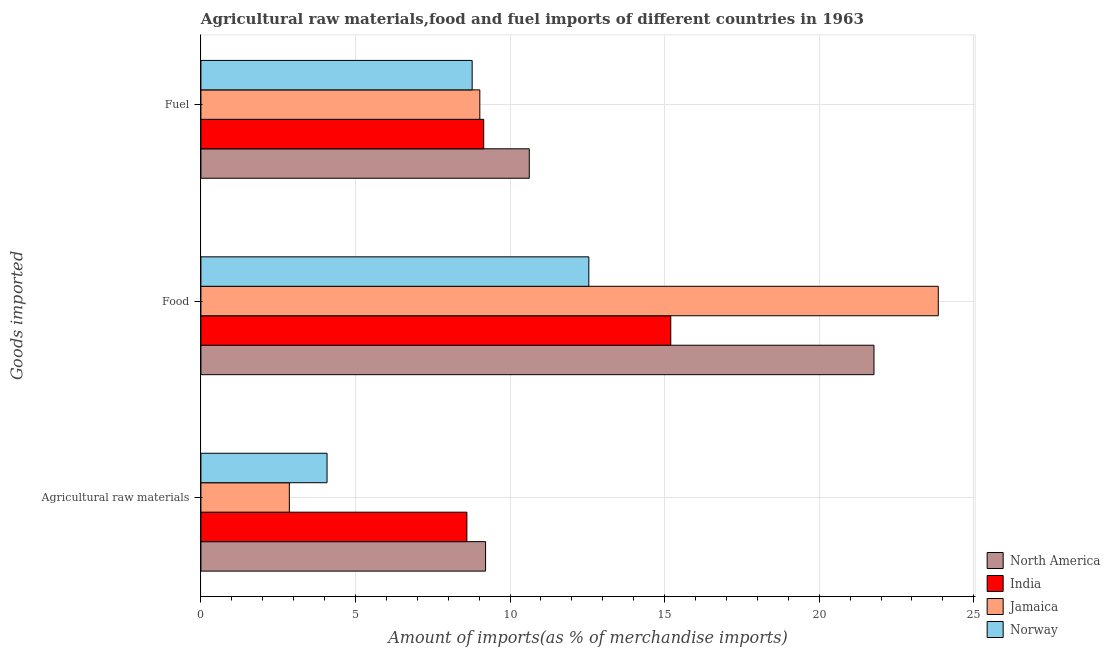How many groups of bars are there?
Offer a very short reply. 3. Are the number of bars per tick equal to the number of legend labels?
Keep it short and to the point. Yes. How many bars are there on the 2nd tick from the top?
Your answer should be very brief. 4. What is the label of the 2nd group of bars from the top?
Ensure brevity in your answer.  Food. What is the percentage of raw materials imports in India?
Offer a very short reply. 8.6. Across all countries, what is the maximum percentage of food imports?
Ensure brevity in your answer.  23.85. Across all countries, what is the minimum percentage of fuel imports?
Your answer should be very brief. 8.77. In which country was the percentage of fuel imports maximum?
Your answer should be compact. North America. In which country was the percentage of food imports minimum?
Your response must be concise. Norway. What is the total percentage of fuel imports in the graph?
Your answer should be very brief. 37.56. What is the difference between the percentage of raw materials imports in India and that in Jamaica?
Give a very brief answer. 5.74. What is the difference between the percentage of fuel imports in India and the percentage of raw materials imports in Jamaica?
Offer a terse response. 6.29. What is the average percentage of raw materials imports per country?
Give a very brief answer. 6.19. What is the difference between the percentage of fuel imports and percentage of raw materials imports in Jamaica?
Ensure brevity in your answer.  6.16. In how many countries, is the percentage of raw materials imports greater than 4 %?
Provide a short and direct response. 3. What is the ratio of the percentage of raw materials imports in Norway to that in North America?
Give a very brief answer. 0.44. Is the difference between the percentage of fuel imports in Norway and Jamaica greater than the difference between the percentage of raw materials imports in Norway and Jamaica?
Ensure brevity in your answer.  No. What is the difference between the highest and the second highest percentage of food imports?
Your answer should be compact. 2.08. What is the difference between the highest and the lowest percentage of fuel imports?
Your answer should be compact. 1.85. Is the sum of the percentage of raw materials imports in India and Norway greater than the maximum percentage of fuel imports across all countries?
Your response must be concise. Yes. How many countries are there in the graph?
Ensure brevity in your answer.  4. Does the graph contain any zero values?
Your answer should be compact. No. How are the legend labels stacked?
Provide a short and direct response. Vertical. What is the title of the graph?
Provide a succinct answer. Agricultural raw materials,food and fuel imports of different countries in 1963. Does "Antigua and Barbuda" appear as one of the legend labels in the graph?
Your response must be concise. No. What is the label or title of the X-axis?
Ensure brevity in your answer.  Amount of imports(as % of merchandise imports). What is the label or title of the Y-axis?
Offer a very short reply. Goods imported. What is the Amount of imports(as % of merchandise imports) of North America in Agricultural raw materials?
Give a very brief answer. 9.21. What is the Amount of imports(as % of merchandise imports) in India in Agricultural raw materials?
Offer a very short reply. 8.6. What is the Amount of imports(as % of merchandise imports) of Jamaica in Agricultural raw materials?
Offer a very short reply. 2.86. What is the Amount of imports(as % of merchandise imports) in Norway in Agricultural raw materials?
Offer a terse response. 4.08. What is the Amount of imports(as % of merchandise imports) in North America in Food?
Keep it short and to the point. 21.77. What is the Amount of imports(as % of merchandise imports) in India in Food?
Make the answer very short. 15.2. What is the Amount of imports(as % of merchandise imports) of Jamaica in Food?
Your answer should be compact. 23.85. What is the Amount of imports(as % of merchandise imports) in Norway in Food?
Your response must be concise. 12.55. What is the Amount of imports(as % of merchandise imports) in North America in Fuel?
Ensure brevity in your answer.  10.62. What is the Amount of imports(as % of merchandise imports) in India in Fuel?
Make the answer very short. 9.15. What is the Amount of imports(as % of merchandise imports) of Jamaica in Fuel?
Ensure brevity in your answer.  9.02. What is the Amount of imports(as % of merchandise imports) in Norway in Fuel?
Ensure brevity in your answer.  8.77. Across all Goods imported, what is the maximum Amount of imports(as % of merchandise imports) of North America?
Offer a very short reply. 21.77. Across all Goods imported, what is the maximum Amount of imports(as % of merchandise imports) in India?
Keep it short and to the point. 15.2. Across all Goods imported, what is the maximum Amount of imports(as % of merchandise imports) in Jamaica?
Keep it short and to the point. 23.85. Across all Goods imported, what is the maximum Amount of imports(as % of merchandise imports) of Norway?
Provide a succinct answer. 12.55. Across all Goods imported, what is the minimum Amount of imports(as % of merchandise imports) in North America?
Make the answer very short. 9.21. Across all Goods imported, what is the minimum Amount of imports(as % of merchandise imports) of India?
Provide a succinct answer. 8.6. Across all Goods imported, what is the minimum Amount of imports(as % of merchandise imports) in Jamaica?
Your answer should be compact. 2.86. Across all Goods imported, what is the minimum Amount of imports(as % of merchandise imports) of Norway?
Make the answer very short. 4.08. What is the total Amount of imports(as % of merchandise imports) of North America in the graph?
Provide a succinct answer. 41.6. What is the total Amount of imports(as % of merchandise imports) of India in the graph?
Ensure brevity in your answer.  32.95. What is the total Amount of imports(as % of merchandise imports) in Jamaica in the graph?
Your response must be concise. 35.73. What is the total Amount of imports(as % of merchandise imports) in Norway in the graph?
Provide a succinct answer. 25.4. What is the difference between the Amount of imports(as % of merchandise imports) of North America in Agricultural raw materials and that in Food?
Your response must be concise. -12.56. What is the difference between the Amount of imports(as % of merchandise imports) of India in Agricultural raw materials and that in Food?
Provide a succinct answer. -6.59. What is the difference between the Amount of imports(as % of merchandise imports) in Jamaica in Agricultural raw materials and that in Food?
Provide a short and direct response. -20.99. What is the difference between the Amount of imports(as % of merchandise imports) in Norway in Agricultural raw materials and that in Food?
Give a very brief answer. -8.47. What is the difference between the Amount of imports(as % of merchandise imports) of North America in Agricultural raw materials and that in Fuel?
Your answer should be compact. -1.41. What is the difference between the Amount of imports(as % of merchandise imports) of India in Agricultural raw materials and that in Fuel?
Your response must be concise. -0.54. What is the difference between the Amount of imports(as % of merchandise imports) of Jamaica in Agricultural raw materials and that in Fuel?
Offer a terse response. -6.16. What is the difference between the Amount of imports(as % of merchandise imports) in Norway in Agricultural raw materials and that in Fuel?
Offer a very short reply. -4.69. What is the difference between the Amount of imports(as % of merchandise imports) of North America in Food and that in Fuel?
Your answer should be very brief. 11.15. What is the difference between the Amount of imports(as % of merchandise imports) in India in Food and that in Fuel?
Provide a succinct answer. 6.05. What is the difference between the Amount of imports(as % of merchandise imports) of Jamaica in Food and that in Fuel?
Your answer should be very brief. 14.83. What is the difference between the Amount of imports(as % of merchandise imports) in Norway in Food and that in Fuel?
Provide a succinct answer. 3.77. What is the difference between the Amount of imports(as % of merchandise imports) of North America in Agricultural raw materials and the Amount of imports(as % of merchandise imports) of India in Food?
Make the answer very short. -5.99. What is the difference between the Amount of imports(as % of merchandise imports) of North America in Agricultural raw materials and the Amount of imports(as % of merchandise imports) of Jamaica in Food?
Offer a very short reply. -14.64. What is the difference between the Amount of imports(as % of merchandise imports) of North America in Agricultural raw materials and the Amount of imports(as % of merchandise imports) of Norway in Food?
Make the answer very short. -3.34. What is the difference between the Amount of imports(as % of merchandise imports) of India in Agricultural raw materials and the Amount of imports(as % of merchandise imports) of Jamaica in Food?
Make the answer very short. -15.25. What is the difference between the Amount of imports(as % of merchandise imports) in India in Agricultural raw materials and the Amount of imports(as % of merchandise imports) in Norway in Food?
Make the answer very short. -3.94. What is the difference between the Amount of imports(as % of merchandise imports) of Jamaica in Agricultural raw materials and the Amount of imports(as % of merchandise imports) of Norway in Food?
Make the answer very short. -9.69. What is the difference between the Amount of imports(as % of merchandise imports) of North America in Agricultural raw materials and the Amount of imports(as % of merchandise imports) of India in Fuel?
Make the answer very short. 0.06. What is the difference between the Amount of imports(as % of merchandise imports) of North America in Agricultural raw materials and the Amount of imports(as % of merchandise imports) of Jamaica in Fuel?
Your answer should be compact. 0.19. What is the difference between the Amount of imports(as % of merchandise imports) in North America in Agricultural raw materials and the Amount of imports(as % of merchandise imports) in Norway in Fuel?
Provide a succinct answer. 0.43. What is the difference between the Amount of imports(as % of merchandise imports) of India in Agricultural raw materials and the Amount of imports(as % of merchandise imports) of Jamaica in Fuel?
Give a very brief answer. -0.42. What is the difference between the Amount of imports(as % of merchandise imports) in India in Agricultural raw materials and the Amount of imports(as % of merchandise imports) in Norway in Fuel?
Give a very brief answer. -0.17. What is the difference between the Amount of imports(as % of merchandise imports) of Jamaica in Agricultural raw materials and the Amount of imports(as % of merchandise imports) of Norway in Fuel?
Your response must be concise. -5.91. What is the difference between the Amount of imports(as % of merchandise imports) in North America in Food and the Amount of imports(as % of merchandise imports) in India in Fuel?
Offer a very short reply. 12.62. What is the difference between the Amount of imports(as % of merchandise imports) in North America in Food and the Amount of imports(as % of merchandise imports) in Jamaica in Fuel?
Your answer should be very brief. 12.75. What is the difference between the Amount of imports(as % of merchandise imports) in North America in Food and the Amount of imports(as % of merchandise imports) in Norway in Fuel?
Your response must be concise. 13. What is the difference between the Amount of imports(as % of merchandise imports) of India in Food and the Amount of imports(as % of merchandise imports) of Jamaica in Fuel?
Your answer should be compact. 6.18. What is the difference between the Amount of imports(as % of merchandise imports) of India in Food and the Amount of imports(as % of merchandise imports) of Norway in Fuel?
Keep it short and to the point. 6.42. What is the difference between the Amount of imports(as % of merchandise imports) in Jamaica in Food and the Amount of imports(as % of merchandise imports) in Norway in Fuel?
Your response must be concise. 15.08. What is the average Amount of imports(as % of merchandise imports) in North America per Goods imported?
Provide a succinct answer. 13.87. What is the average Amount of imports(as % of merchandise imports) of India per Goods imported?
Keep it short and to the point. 10.98. What is the average Amount of imports(as % of merchandise imports) in Jamaica per Goods imported?
Your answer should be compact. 11.91. What is the average Amount of imports(as % of merchandise imports) in Norway per Goods imported?
Ensure brevity in your answer.  8.47. What is the difference between the Amount of imports(as % of merchandise imports) in North America and Amount of imports(as % of merchandise imports) in India in Agricultural raw materials?
Your answer should be compact. 0.6. What is the difference between the Amount of imports(as % of merchandise imports) of North America and Amount of imports(as % of merchandise imports) of Jamaica in Agricultural raw materials?
Give a very brief answer. 6.35. What is the difference between the Amount of imports(as % of merchandise imports) of North America and Amount of imports(as % of merchandise imports) of Norway in Agricultural raw materials?
Keep it short and to the point. 5.13. What is the difference between the Amount of imports(as % of merchandise imports) of India and Amount of imports(as % of merchandise imports) of Jamaica in Agricultural raw materials?
Your answer should be compact. 5.74. What is the difference between the Amount of imports(as % of merchandise imports) in India and Amount of imports(as % of merchandise imports) in Norway in Agricultural raw materials?
Ensure brevity in your answer.  4.52. What is the difference between the Amount of imports(as % of merchandise imports) of Jamaica and Amount of imports(as % of merchandise imports) of Norway in Agricultural raw materials?
Keep it short and to the point. -1.22. What is the difference between the Amount of imports(as % of merchandise imports) in North America and Amount of imports(as % of merchandise imports) in India in Food?
Make the answer very short. 6.57. What is the difference between the Amount of imports(as % of merchandise imports) in North America and Amount of imports(as % of merchandise imports) in Jamaica in Food?
Your answer should be very brief. -2.08. What is the difference between the Amount of imports(as % of merchandise imports) of North America and Amount of imports(as % of merchandise imports) of Norway in Food?
Keep it short and to the point. 9.22. What is the difference between the Amount of imports(as % of merchandise imports) of India and Amount of imports(as % of merchandise imports) of Jamaica in Food?
Provide a succinct answer. -8.65. What is the difference between the Amount of imports(as % of merchandise imports) of India and Amount of imports(as % of merchandise imports) of Norway in Food?
Your response must be concise. 2.65. What is the difference between the Amount of imports(as % of merchandise imports) of Jamaica and Amount of imports(as % of merchandise imports) of Norway in Food?
Your answer should be very brief. 11.3. What is the difference between the Amount of imports(as % of merchandise imports) in North America and Amount of imports(as % of merchandise imports) in India in Fuel?
Offer a terse response. 1.47. What is the difference between the Amount of imports(as % of merchandise imports) in North America and Amount of imports(as % of merchandise imports) in Jamaica in Fuel?
Your answer should be very brief. 1.6. What is the difference between the Amount of imports(as % of merchandise imports) in North America and Amount of imports(as % of merchandise imports) in Norway in Fuel?
Your response must be concise. 1.85. What is the difference between the Amount of imports(as % of merchandise imports) of India and Amount of imports(as % of merchandise imports) of Jamaica in Fuel?
Offer a very short reply. 0.13. What is the difference between the Amount of imports(as % of merchandise imports) of India and Amount of imports(as % of merchandise imports) of Norway in Fuel?
Offer a terse response. 0.37. What is the difference between the Amount of imports(as % of merchandise imports) of Jamaica and Amount of imports(as % of merchandise imports) of Norway in Fuel?
Your answer should be compact. 0.25. What is the ratio of the Amount of imports(as % of merchandise imports) of North America in Agricultural raw materials to that in Food?
Ensure brevity in your answer.  0.42. What is the ratio of the Amount of imports(as % of merchandise imports) in India in Agricultural raw materials to that in Food?
Your answer should be compact. 0.57. What is the ratio of the Amount of imports(as % of merchandise imports) in Jamaica in Agricultural raw materials to that in Food?
Your answer should be compact. 0.12. What is the ratio of the Amount of imports(as % of merchandise imports) in Norway in Agricultural raw materials to that in Food?
Your answer should be very brief. 0.33. What is the ratio of the Amount of imports(as % of merchandise imports) in North America in Agricultural raw materials to that in Fuel?
Make the answer very short. 0.87. What is the ratio of the Amount of imports(as % of merchandise imports) in India in Agricultural raw materials to that in Fuel?
Ensure brevity in your answer.  0.94. What is the ratio of the Amount of imports(as % of merchandise imports) in Jamaica in Agricultural raw materials to that in Fuel?
Make the answer very short. 0.32. What is the ratio of the Amount of imports(as % of merchandise imports) in Norway in Agricultural raw materials to that in Fuel?
Ensure brevity in your answer.  0.47. What is the ratio of the Amount of imports(as % of merchandise imports) of North America in Food to that in Fuel?
Make the answer very short. 2.05. What is the ratio of the Amount of imports(as % of merchandise imports) in India in Food to that in Fuel?
Offer a very short reply. 1.66. What is the ratio of the Amount of imports(as % of merchandise imports) of Jamaica in Food to that in Fuel?
Your answer should be very brief. 2.64. What is the ratio of the Amount of imports(as % of merchandise imports) of Norway in Food to that in Fuel?
Offer a terse response. 1.43. What is the difference between the highest and the second highest Amount of imports(as % of merchandise imports) of North America?
Offer a terse response. 11.15. What is the difference between the highest and the second highest Amount of imports(as % of merchandise imports) of India?
Keep it short and to the point. 6.05. What is the difference between the highest and the second highest Amount of imports(as % of merchandise imports) in Jamaica?
Give a very brief answer. 14.83. What is the difference between the highest and the second highest Amount of imports(as % of merchandise imports) in Norway?
Provide a succinct answer. 3.77. What is the difference between the highest and the lowest Amount of imports(as % of merchandise imports) in North America?
Provide a short and direct response. 12.56. What is the difference between the highest and the lowest Amount of imports(as % of merchandise imports) in India?
Your response must be concise. 6.59. What is the difference between the highest and the lowest Amount of imports(as % of merchandise imports) of Jamaica?
Make the answer very short. 20.99. What is the difference between the highest and the lowest Amount of imports(as % of merchandise imports) of Norway?
Make the answer very short. 8.47. 